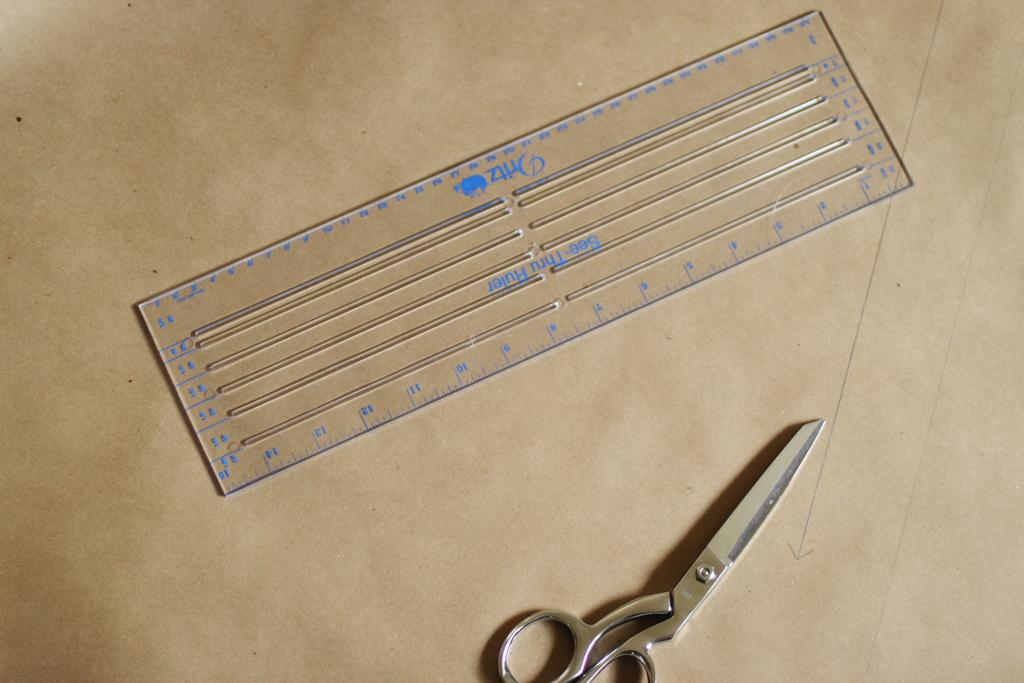<image>
Provide a brief description of the given image. A Dritz brand sewing ruler and template next to a pair of scissors. 